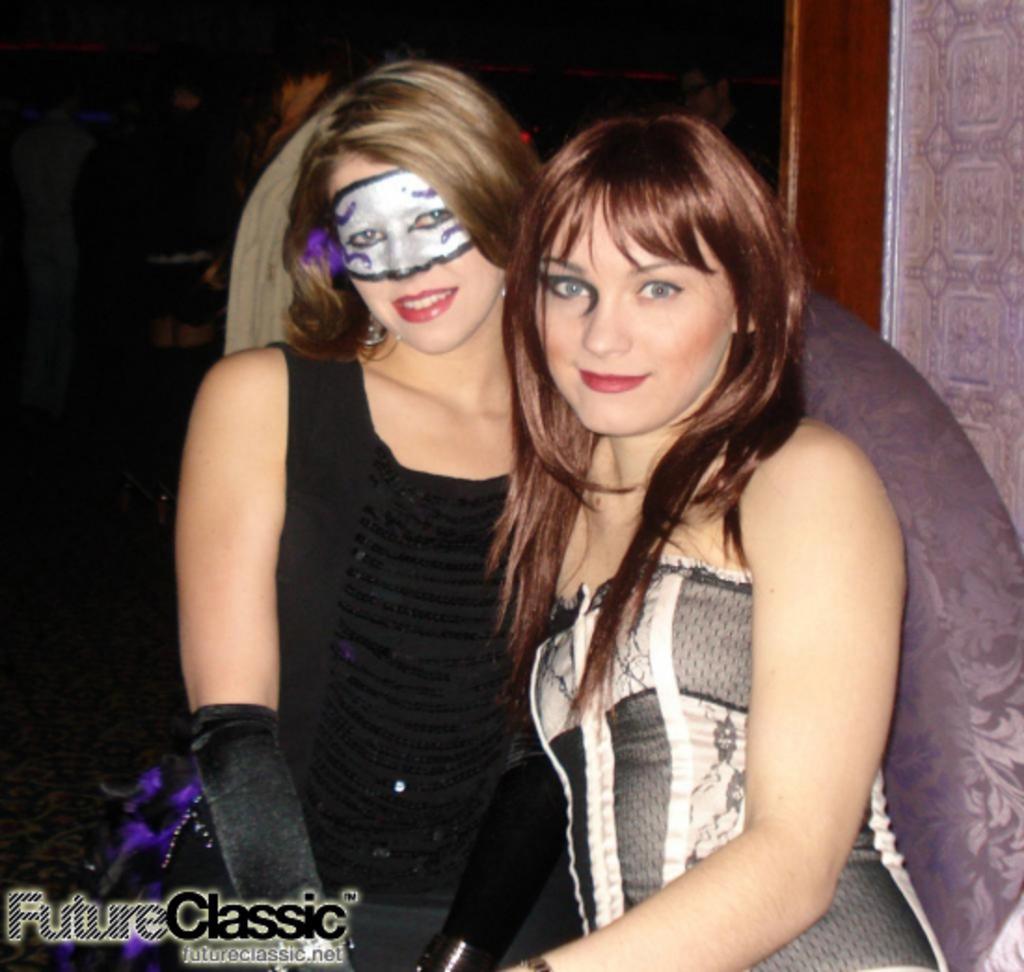In one or two sentences, can you explain what this image depicts? In this picture I can see couple of women standing and I can see painting on a woman's face and few people standing in the back and I can see text at the bottom left corner of the picture. 